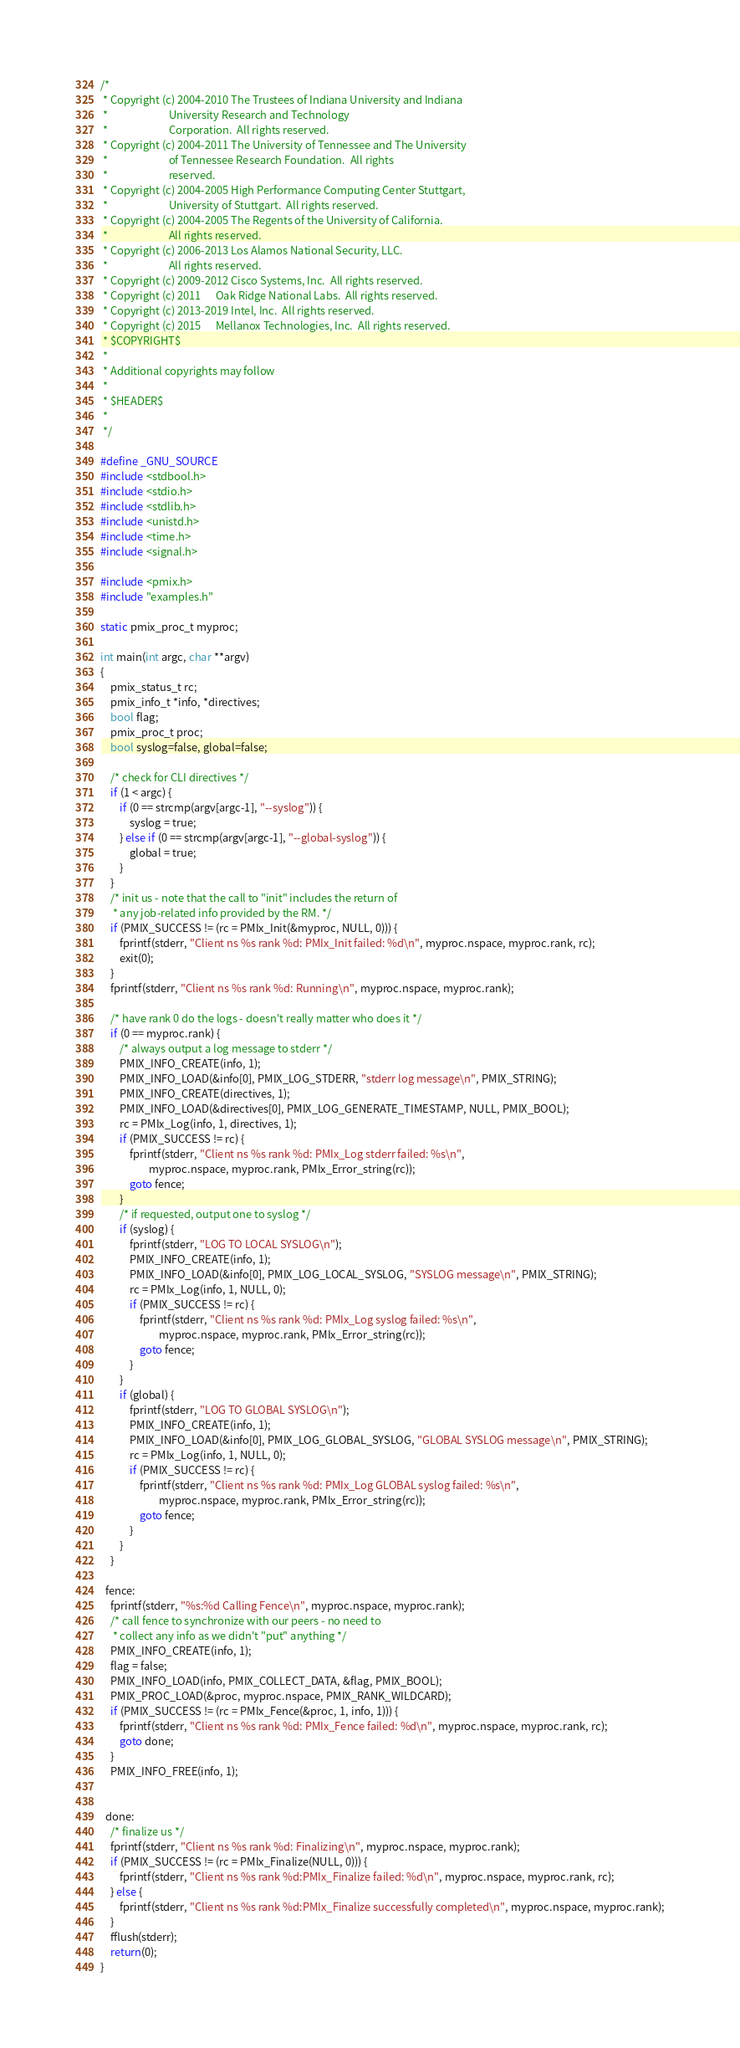<code> <loc_0><loc_0><loc_500><loc_500><_C_>/*
 * Copyright (c) 2004-2010 The Trustees of Indiana University and Indiana
 *                         University Research and Technology
 *                         Corporation.  All rights reserved.
 * Copyright (c) 2004-2011 The University of Tennessee and The University
 *                         of Tennessee Research Foundation.  All rights
 *                         reserved.
 * Copyright (c) 2004-2005 High Performance Computing Center Stuttgart,
 *                         University of Stuttgart.  All rights reserved.
 * Copyright (c) 2004-2005 The Regents of the University of California.
 *                         All rights reserved.
 * Copyright (c) 2006-2013 Los Alamos National Security, LLC.
 *                         All rights reserved.
 * Copyright (c) 2009-2012 Cisco Systems, Inc.  All rights reserved.
 * Copyright (c) 2011      Oak Ridge National Labs.  All rights reserved.
 * Copyright (c) 2013-2019 Intel, Inc.  All rights reserved.
 * Copyright (c) 2015      Mellanox Technologies, Inc.  All rights reserved.
 * $COPYRIGHT$
 *
 * Additional copyrights may follow
 *
 * $HEADER$
 *
 */

#define _GNU_SOURCE
#include <stdbool.h>
#include <stdio.h>
#include <stdlib.h>
#include <unistd.h>
#include <time.h>
#include <signal.h>

#include <pmix.h>
#include "examples.h"

static pmix_proc_t myproc;

int main(int argc, char **argv)
{
    pmix_status_t rc;
    pmix_info_t *info, *directives;
    bool flag;
    pmix_proc_t proc;
    bool syslog=false, global=false;

    /* check for CLI directives */
    if (1 < argc) {
        if (0 == strcmp(argv[argc-1], "--syslog")) {
            syslog = true;
        } else if (0 == strcmp(argv[argc-1], "--global-syslog")) {
            global = true;
        }
    }
    /* init us - note that the call to "init" includes the return of
     * any job-related info provided by the RM. */
    if (PMIX_SUCCESS != (rc = PMIx_Init(&myproc, NULL, 0))) {
        fprintf(stderr, "Client ns %s rank %d: PMIx_Init failed: %d\n", myproc.nspace, myproc.rank, rc);
        exit(0);
    }
    fprintf(stderr, "Client ns %s rank %d: Running\n", myproc.nspace, myproc.rank);

    /* have rank 0 do the logs - doesn't really matter who does it */
    if (0 == myproc.rank) {
        /* always output a log message to stderr */
        PMIX_INFO_CREATE(info, 1);
        PMIX_INFO_LOAD(&info[0], PMIX_LOG_STDERR, "stderr log message\n", PMIX_STRING);
        PMIX_INFO_CREATE(directives, 1);
        PMIX_INFO_LOAD(&directives[0], PMIX_LOG_GENERATE_TIMESTAMP, NULL, PMIX_BOOL);
        rc = PMIx_Log(info, 1, directives, 1);
        if (PMIX_SUCCESS != rc) {
            fprintf(stderr, "Client ns %s rank %d: PMIx_Log stderr failed: %s\n",
                    myproc.nspace, myproc.rank, PMIx_Error_string(rc));
            goto fence;
        }
        /* if requested, output one to syslog */
        if (syslog) {
            fprintf(stderr, "LOG TO LOCAL SYSLOG\n");
            PMIX_INFO_CREATE(info, 1);
            PMIX_INFO_LOAD(&info[0], PMIX_LOG_LOCAL_SYSLOG, "SYSLOG message\n", PMIX_STRING);
            rc = PMIx_Log(info, 1, NULL, 0);
            if (PMIX_SUCCESS != rc) {
                fprintf(stderr, "Client ns %s rank %d: PMIx_Log syslog failed: %s\n",
                        myproc.nspace, myproc.rank, PMIx_Error_string(rc));
                goto fence;
            }
        }
        if (global) {
            fprintf(stderr, "LOG TO GLOBAL SYSLOG\n");
            PMIX_INFO_CREATE(info, 1);
            PMIX_INFO_LOAD(&info[0], PMIX_LOG_GLOBAL_SYSLOG, "GLOBAL SYSLOG message\n", PMIX_STRING);
            rc = PMIx_Log(info, 1, NULL, 0);
            if (PMIX_SUCCESS != rc) {
                fprintf(stderr, "Client ns %s rank %d: PMIx_Log GLOBAL syslog failed: %s\n",
                        myproc.nspace, myproc.rank, PMIx_Error_string(rc));
                goto fence;
            }
        }
    }

  fence:
    fprintf(stderr, "%s:%d Calling Fence\n", myproc.nspace, myproc.rank);
    /* call fence to synchronize with our peers - no need to
     * collect any info as we didn't "put" anything */
    PMIX_INFO_CREATE(info, 1);
    flag = false;
    PMIX_INFO_LOAD(info, PMIX_COLLECT_DATA, &flag, PMIX_BOOL);
    PMIX_PROC_LOAD(&proc, myproc.nspace, PMIX_RANK_WILDCARD);
    if (PMIX_SUCCESS != (rc = PMIx_Fence(&proc, 1, info, 1))) {
        fprintf(stderr, "Client ns %s rank %d: PMIx_Fence failed: %d\n", myproc.nspace, myproc.rank, rc);
        goto done;
    }
    PMIX_INFO_FREE(info, 1);


  done:
    /* finalize us */
    fprintf(stderr, "Client ns %s rank %d: Finalizing\n", myproc.nspace, myproc.rank);
    if (PMIX_SUCCESS != (rc = PMIx_Finalize(NULL, 0))) {
        fprintf(stderr, "Client ns %s rank %d:PMIx_Finalize failed: %d\n", myproc.nspace, myproc.rank, rc);
    } else {
        fprintf(stderr, "Client ns %s rank %d:PMIx_Finalize successfully completed\n", myproc.nspace, myproc.rank);
    }
    fflush(stderr);
    return(0);
}
</code> 